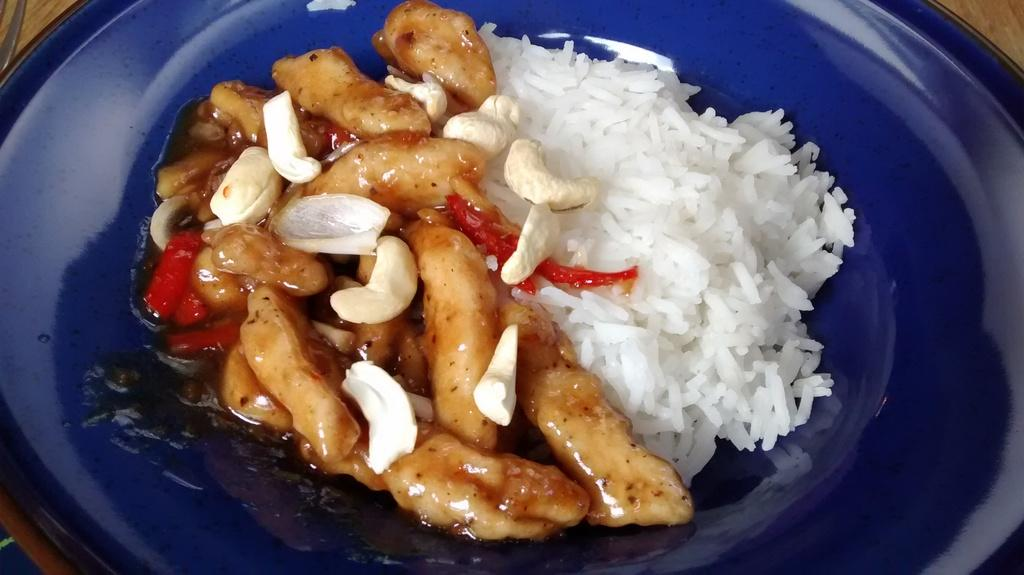What is on the plate that is visible in the image? There are food items on a plate in the image. Where is the plate located in the image? The plate is visible on a wooden surface. What can be seen in the top left of the image? There is an object visible in the top left of the image. How many seeds can be seen on the trees in the image? There are no trees visible in the image, so it is not possible to determine the number of seeds on them. 